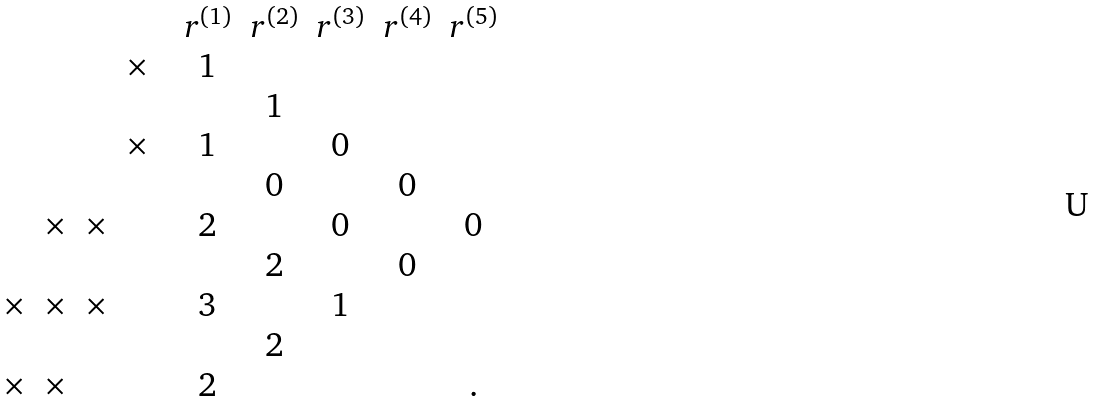Convert formula to latex. <formula><loc_0><loc_0><loc_500><loc_500>\begin{matrix} & & & & & r ^ { ( 1 ) } & r ^ { ( 2 ) } & r ^ { ( 3 ) } & r ^ { ( 4 ) } & r ^ { ( 5 ) } \\ & & & \times & & 1 & & & & \\ & & & & & & 1 & & & \\ & & & \times & & 1 & & 0 & & \\ & & & & & & 0 & & 0 & \\ & \times & \times & & & 2 & & 0 & & 0 \\ & & & & & & 2 & & 0 & \\ \times & \times & \times & & & 3 & & 1 & & \\ & & & & & & 2 & & & \\ \times & \times & & & & 2 & & & & . \end{matrix}</formula> 